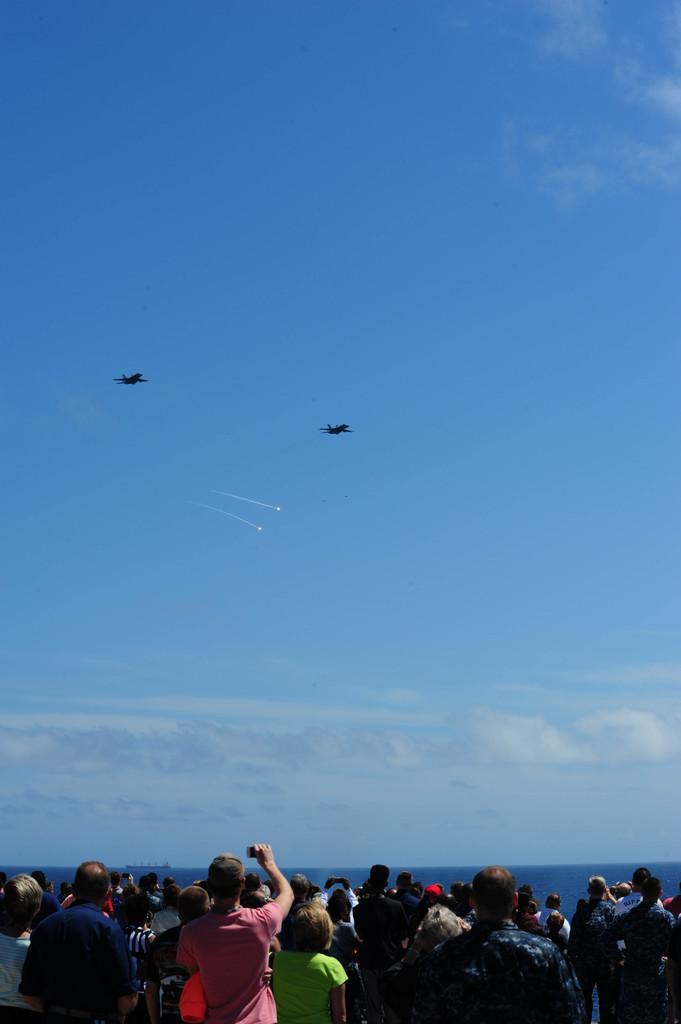What type of vehicles are in the image? There are planes and rockets in the image. Where are the planes and rockets located? The planes and rockets are in the air. What are the people in the image doing? The people are standing and watching in the image. What type of nut is being used to hold the rocket in place in the image? There is no nut present in the image, and the rockets are not being held in place by any visible means. 